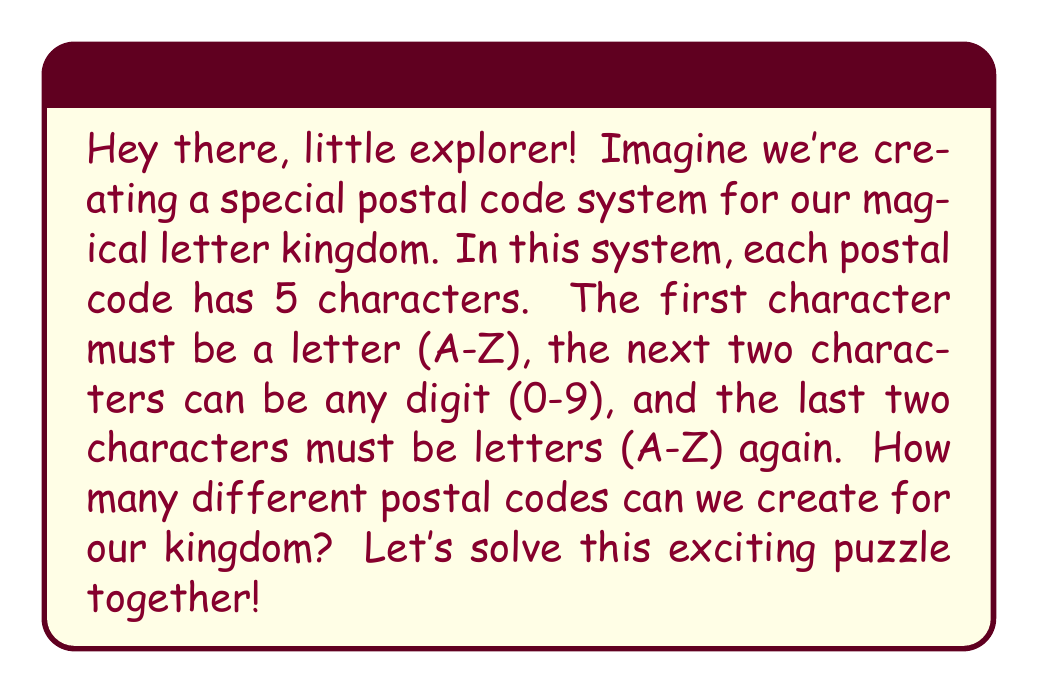Can you solve this math problem? Alright, let's break this down step by step:

1) For the first character, we have 26 choices (A-Z).

2) For the second and third characters, we have 10 choices each (0-9).

3) For the fourth and fifth characters, we have 26 choices each (A-Z).

Now, let's use the multiplication principle. This principle states that if we have a series of independent choices, the total number of possible outcomes is the product of the number of possibilities for each choice.

So, we can calculate the total number of possible postal codes as:

$$ \text{Total combinations} = 26 \times 10 \times 10 \times 26 \times 26 $$

Let's calculate this:
$$ 26 \times 10 \times 10 \times 26 \times 26 = 1,757,600 $$

Wow! That's a lot of possible postal codes for our magical kingdom!
Answer: The total number of possible postal code combinations is 1,757,600. 